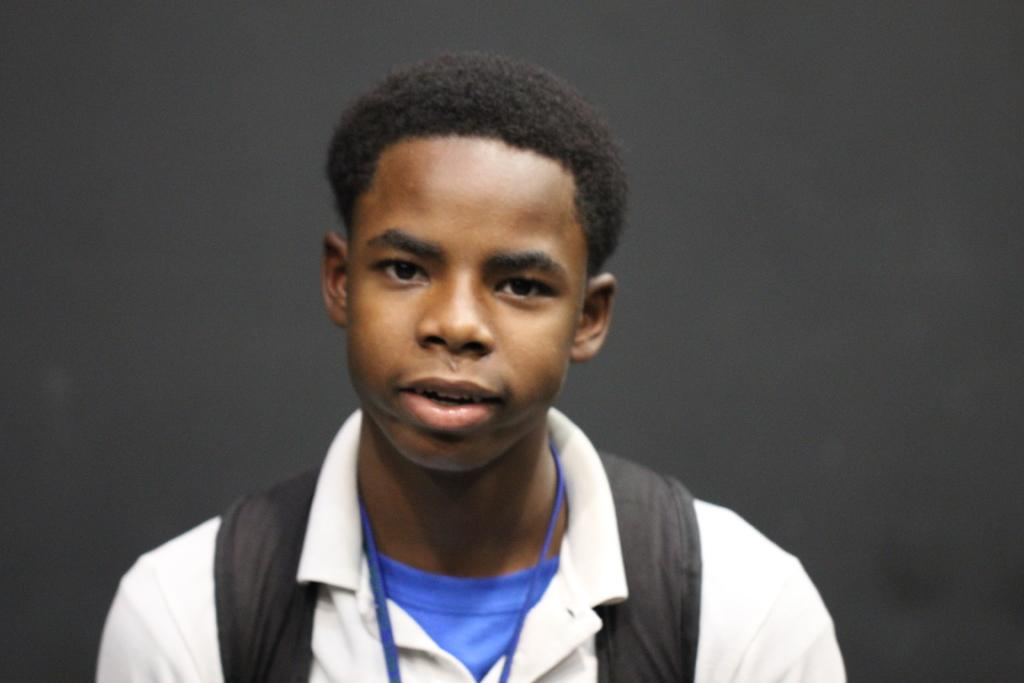What is the main subject of the image? There is a man in the image. What is the man doing in the image? The man is standing in the image. What is the man's facial expression in the image? The man is smiling in the image. What can be seen behind the man in the image? There is a wall behind the man in the image. What type of brick is the man using to make jelly in the image? There is no brick or jelly present in the image, and the man is not making jelly. 